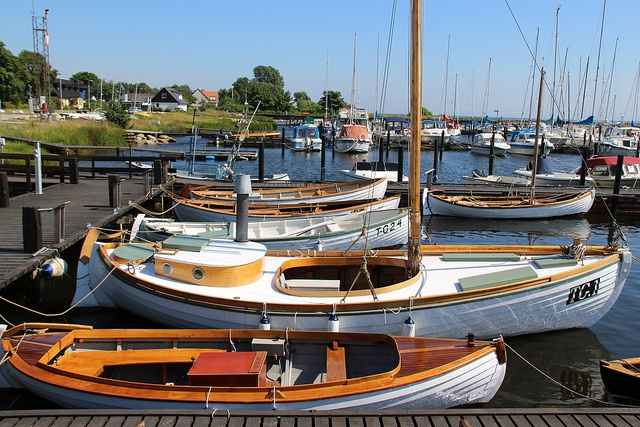Describe the objects in this image and their specific colors. I can see boat in lightblue, white, black, gray, and darkgray tones, boat in lightblue, black, red, maroon, and brown tones, boat in lightblue, black, gray, darkgray, and lightgray tones, boat in lightblue, darkgray, lightgray, and gray tones, and boat in lightblue, black, and gray tones in this image. 